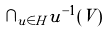Convert formula to latex. <formula><loc_0><loc_0><loc_500><loc_500>\cap _ { u \in H } u ^ { - 1 } ( V )</formula> 